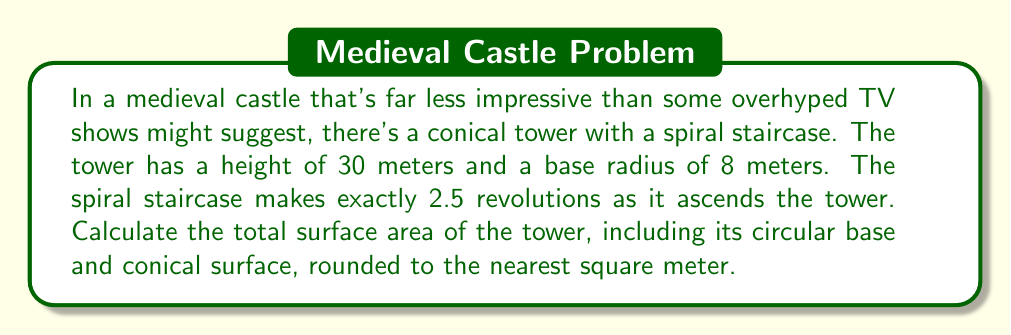Solve this math problem. Let's approach this step-by-step:

1) First, we need to calculate the slant height of the cone. We can do this using the Pythagorean theorem:

   $$ l = \sqrt{r^2 + h^2} = \sqrt{8^2 + 30^2} = \sqrt{64 + 900} = \sqrt{964} \approx 31.05 \text{ m} $$

2) Now, we can calculate the lateral surface area of the cone:

   $$ A_{\text{lateral}} = \pi r l = \pi \cdot 8 \cdot 31.05 \approx 779.85 \text{ m}^2 $$

3) The area of the circular base is:

   $$ A_{\text{base}} = \pi r^2 = \pi \cdot 8^2 = 64\pi \approx 201.06 \text{ m}^2 $$

4) The total surface area is the sum of the lateral surface area and the base area:

   $$ A_{\text{total}} = A_{\text{lateral}} + A_{\text{base}} \approx 779.85 + 201.06 = 980.91 \text{ m}^2 $$

5) Rounding to the nearest square meter:

   $$ A_{\text{total}} \approx 981 \text{ m}^2 $$

Note: The spiral staircase information is not relevant for calculating the surface area of the tower.
Answer: $981 \text{ m}^2$ 